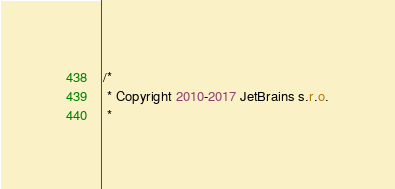<code> <loc_0><loc_0><loc_500><loc_500><_Kotlin_>/*
 * Copyright 2010-2017 JetBrains s.r.o.
 *</code> 